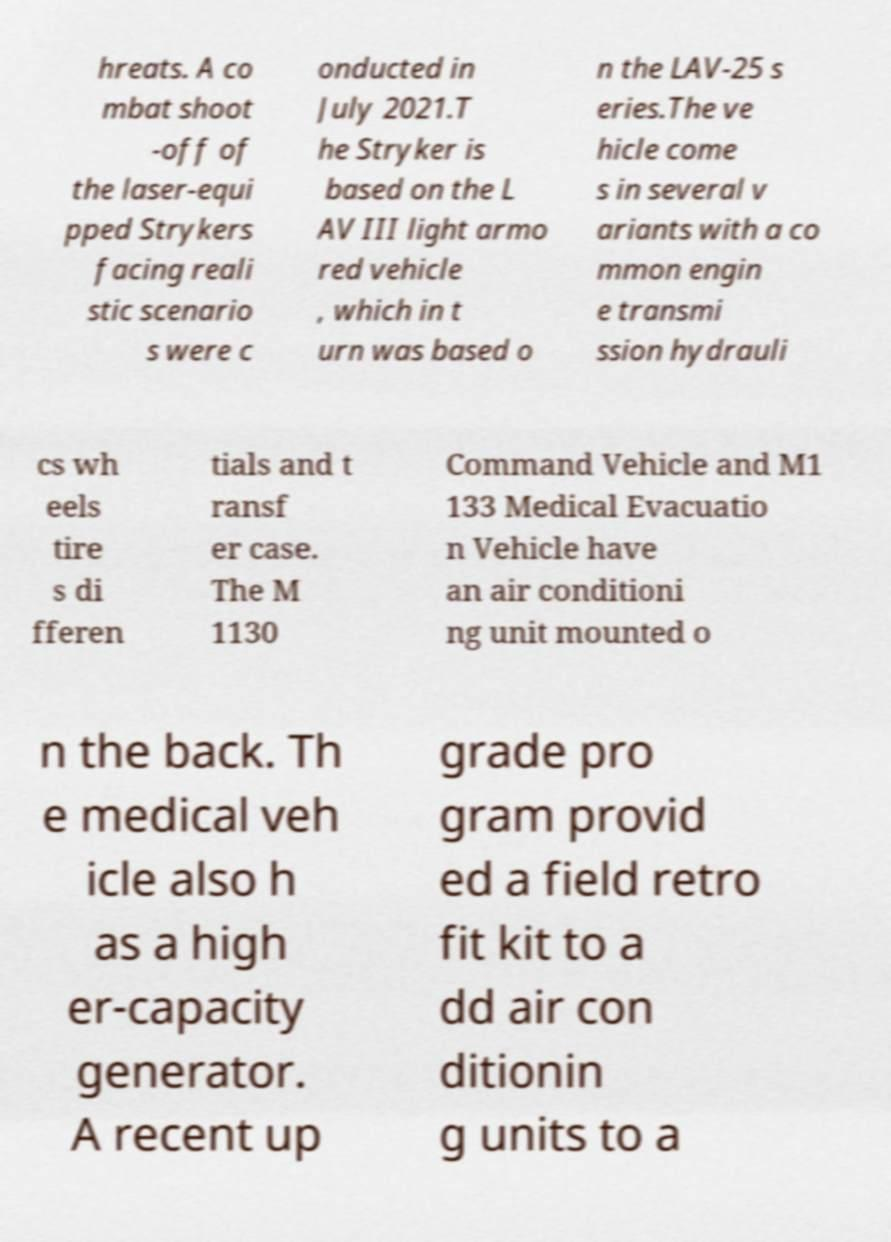Can you accurately transcribe the text from the provided image for me? hreats. A co mbat shoot -off of the laser-equi pped Strykers facing reali stic scenario s were c onducted in July 2021.T he Stryker is based on the L AV III light armo red vehicle , which in t urn was based o n the LAV-25 s eries.The ve hicle come s in several v ariants with a co mmon engin e transmi ssion hydrauli cs wh eels tire s di fferen tials and t ransf er case. The M 1130 Command Vehicle and M1 133 Medical Evacuatio n Vehicle have an air conditioni ng unit mounted o n the back. Th e medical veh icle also h as a high er-capacity generator. A recent up grade pro gram provid ed a field retro fit kit to a dd air con ditionin g units to a 